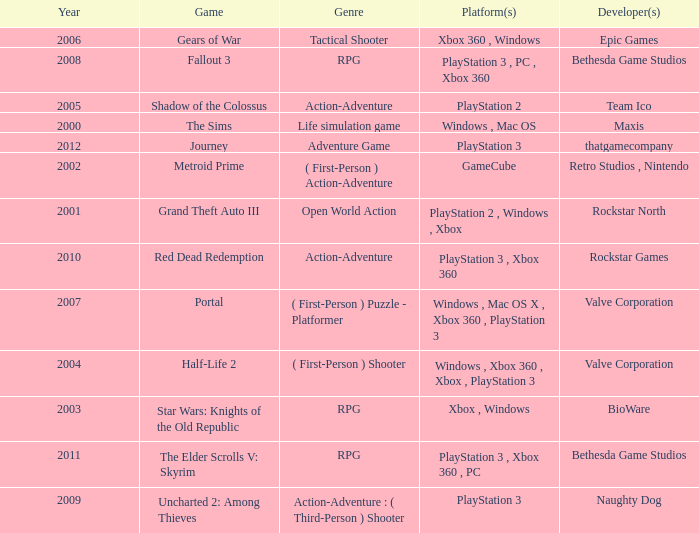What's the platform that has Rockstar Games as the developer? PlayStation 3 , Xbox 360. 